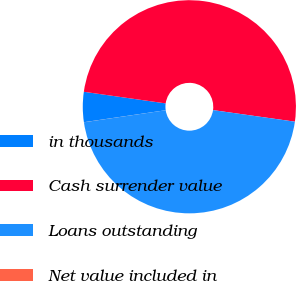Convert chart. <chart><loc_0><loc_0><loc_500><loc_500><pie_chart><fcel>in thousands<fcel>Cash surrender value<fcel>Loans outstanding<fcel>Net value included in<nl><fcel>4.56%<fcel>49.99%<fcel>45.44%<fcel>0.01%<nl></chart> 